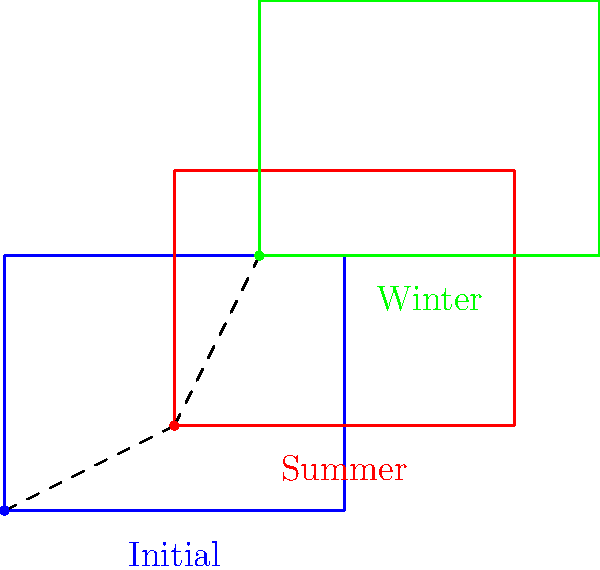Given the seasonal migration pattern of a specific fish species shown in the diagram, where blue represents the initial position, red the summer position, and green the winter position, determine the composite transformation that moves the school from its initial position to its winter position. Express your answer as a combination of translation vectors. To find the composite transformation, we need to analyze the movements step-by-step:

1. Initial position to summer position (blue to red):
   - Translation vector: $\vec{v_1} = (2,1)$

2. Summer position to winter position (red to green):
   - Translation vector: $\vec{v_2} = (1,2)$

3. To get from the initial position to the winter position, we need to compose these translations:
   - Composite vector: $\vec{v} = \vec{v_1} + \vec{v_2}$

4. Calculate the composite vector:
   $\vec{v} = (2,1) + (1,2) = (3,3)$

Therefore, the composite transformation from the initial position to the winter position is a single translation by the vector $(3,3)$.
Answer: Translation by vector $(3,3)$ 